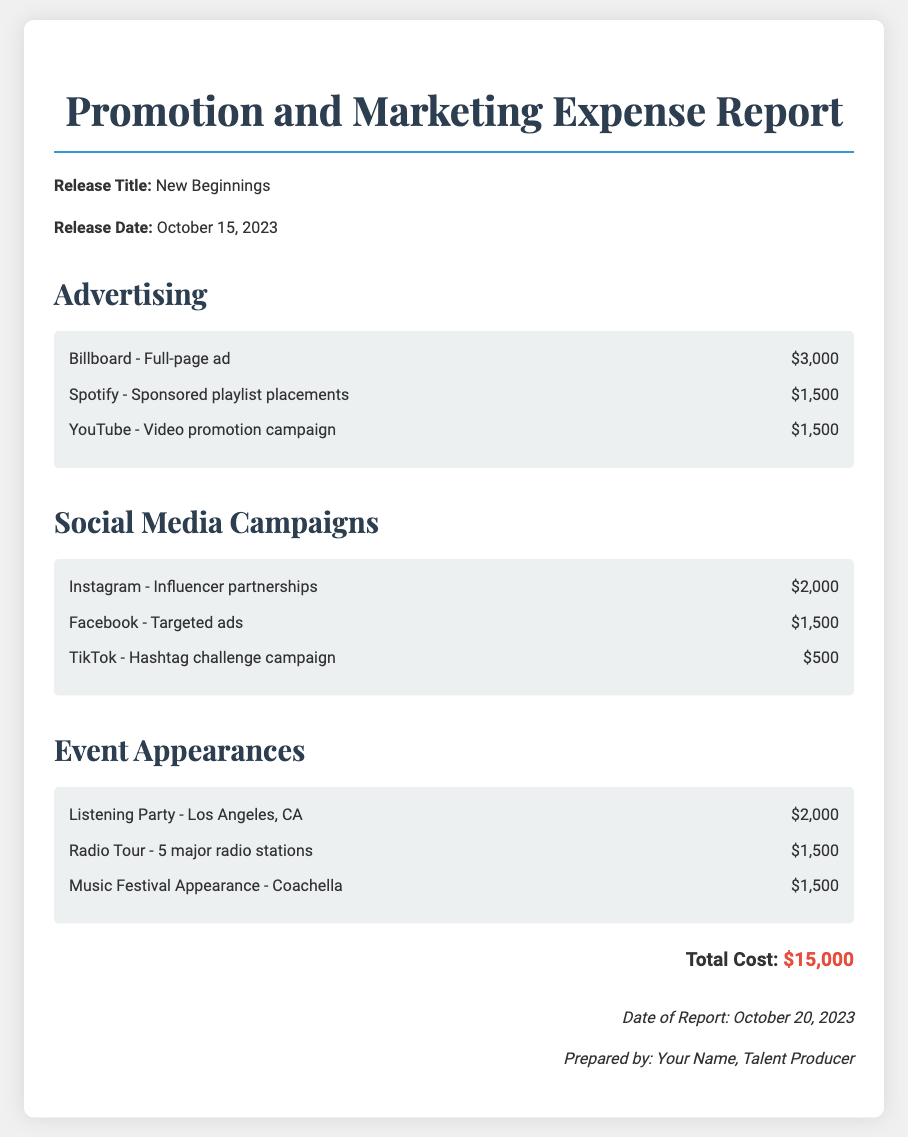What is the release title? The release title is specified at the beginning of the document.
Answer: New Beginnings What is the release date? The release date is directly mentioned alongside the release title.
Answer: October 15, 2023 How much was spent on the Billboard ad? This amount is detailed under the Advertising category.
Answer: $3,000 What is the total cost of the promotion and marketing expenses? The total cost is calculated from all the individual expenses listed in the document.
Answer: $15,000 Which platform had an influencer partnership expense? The document lists this under Social Media Campaigns.
Answer: Instagram How much was allocated for the Music Festival Appearance? This cost is itemized in the Event Appearances section.
Answer: $1,500 Who prepared this report? This information is noted in the footer section of the document.
Answer: Your Name What is the date of the report? The date is specified at the bottom of the document.
Answer: October 20, 2023 How much was spent on Facebook ads? This amount is mentioned in the Social Media Campaigns section.
Answer: $1,500 